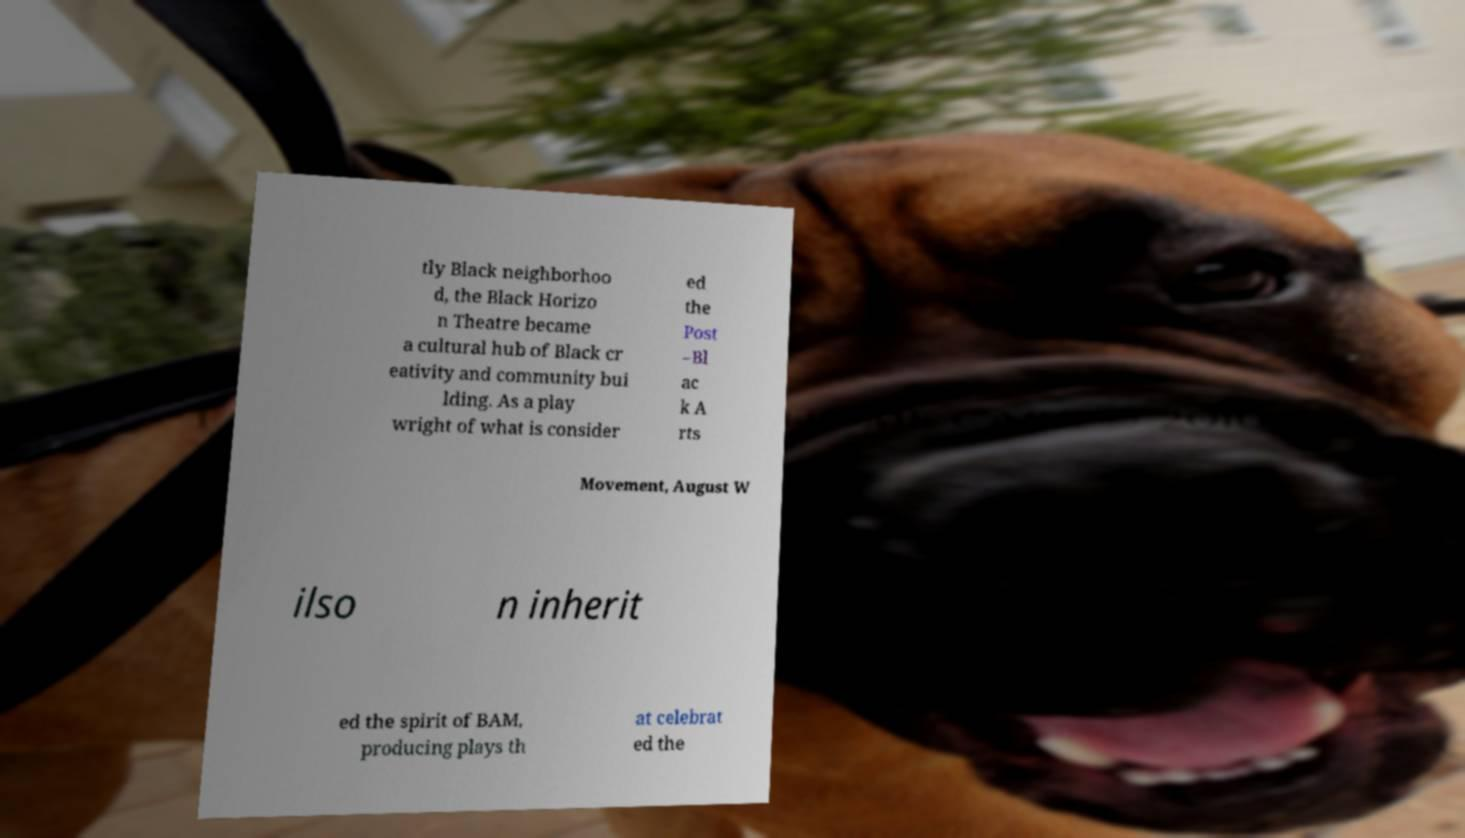Can you read and provide the text displayed in the image?This photo seems to have some interesting text. Can you extract and type it out for me? tly Black neighborhoo d, the Black Horizo n Theatre became a cultural hub of Black cr eativity and community bui lding. As a play wright of what is consider ed the Post –Bl ac k A rts Movement, August W ilso n inherit ed the spirit of BAM, producing plays th at celebrat ed the 